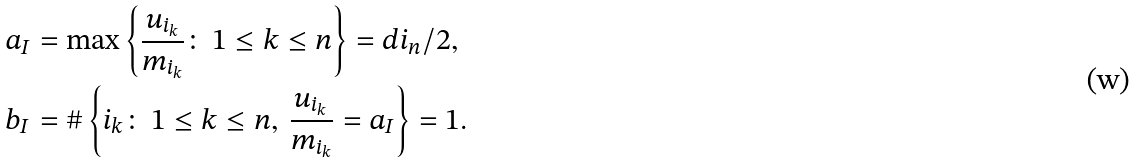<formula> <loc_0><loc_0><loc_500><loc_500>a _ { I } & = \max \left \{ \frac { u _ { i _ { k } } } { m _ { i _ { k } } } \colon \, 1 \leq k \leq n \right \} = d i _ { n } / 2 , \\ b _ { I } & = \# \left \{ i _ { k } \colon \, 1 \leq k \leq n , \, \frac { u _ { i _ { k } } } { m _ { i _ { k } } } = a _ { I } \right \} = 1 .</formula> 